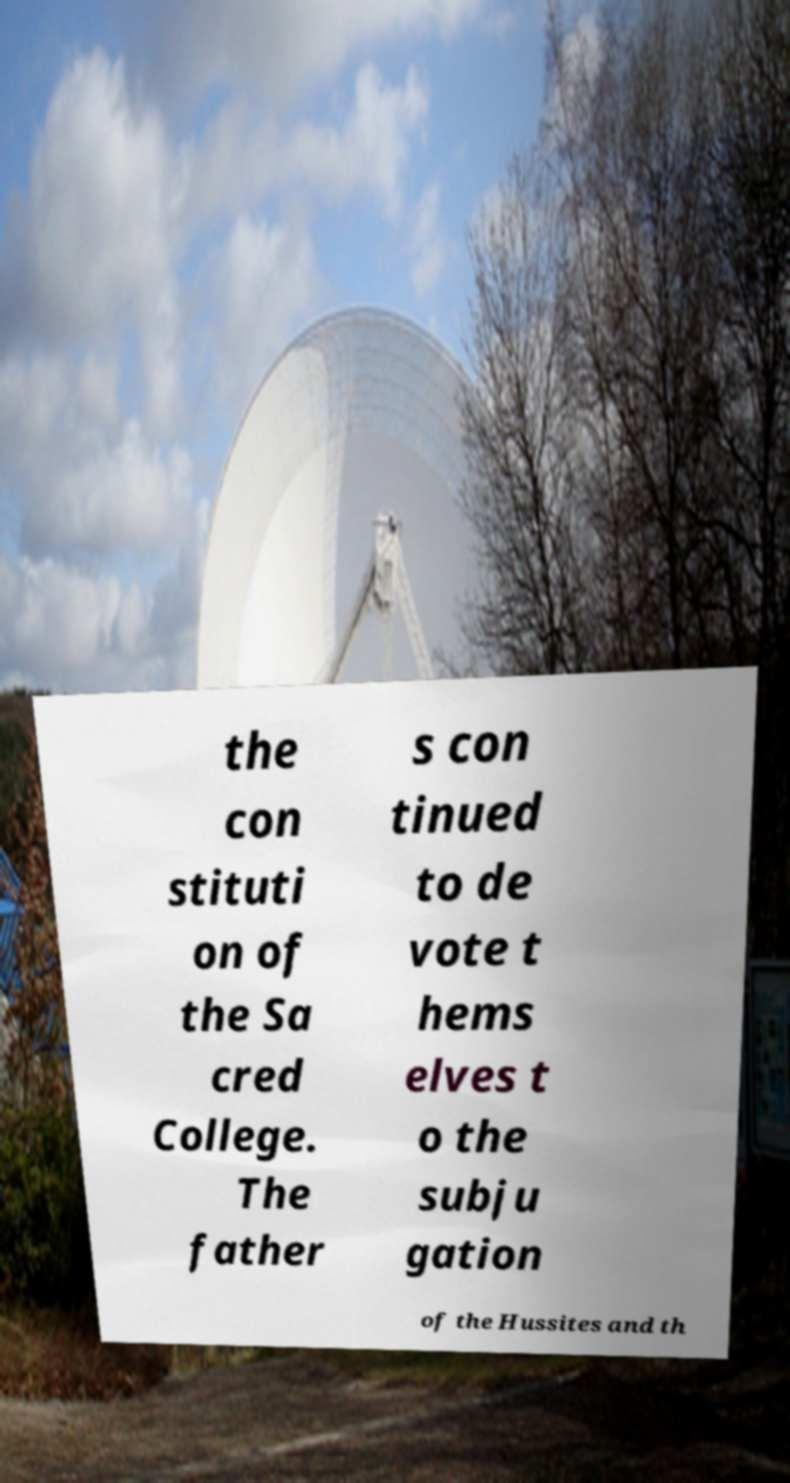Can you accurately transcribe the text from the provided image for me? the con stituti on of the Sa cred College. The father s con tinued to de vote t hems elves t o the subju gation of the Hussites and th 